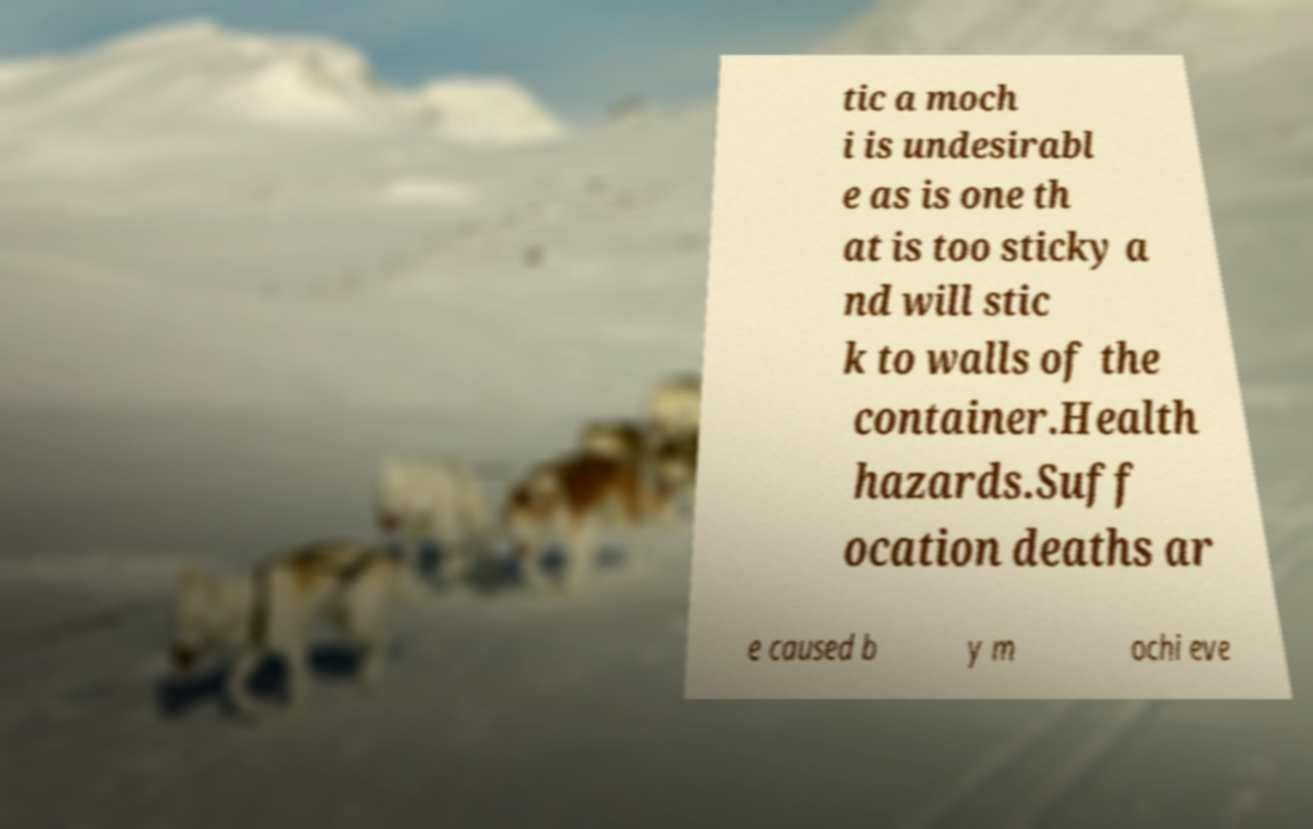Please identify and transcribe the text found in this image. tic a moch i is undesirabl e as is one th at is too sticky a nd will stic k to walls of the container.Health hazards.Suff ocation deaths ar e caused b y m ochi eve 